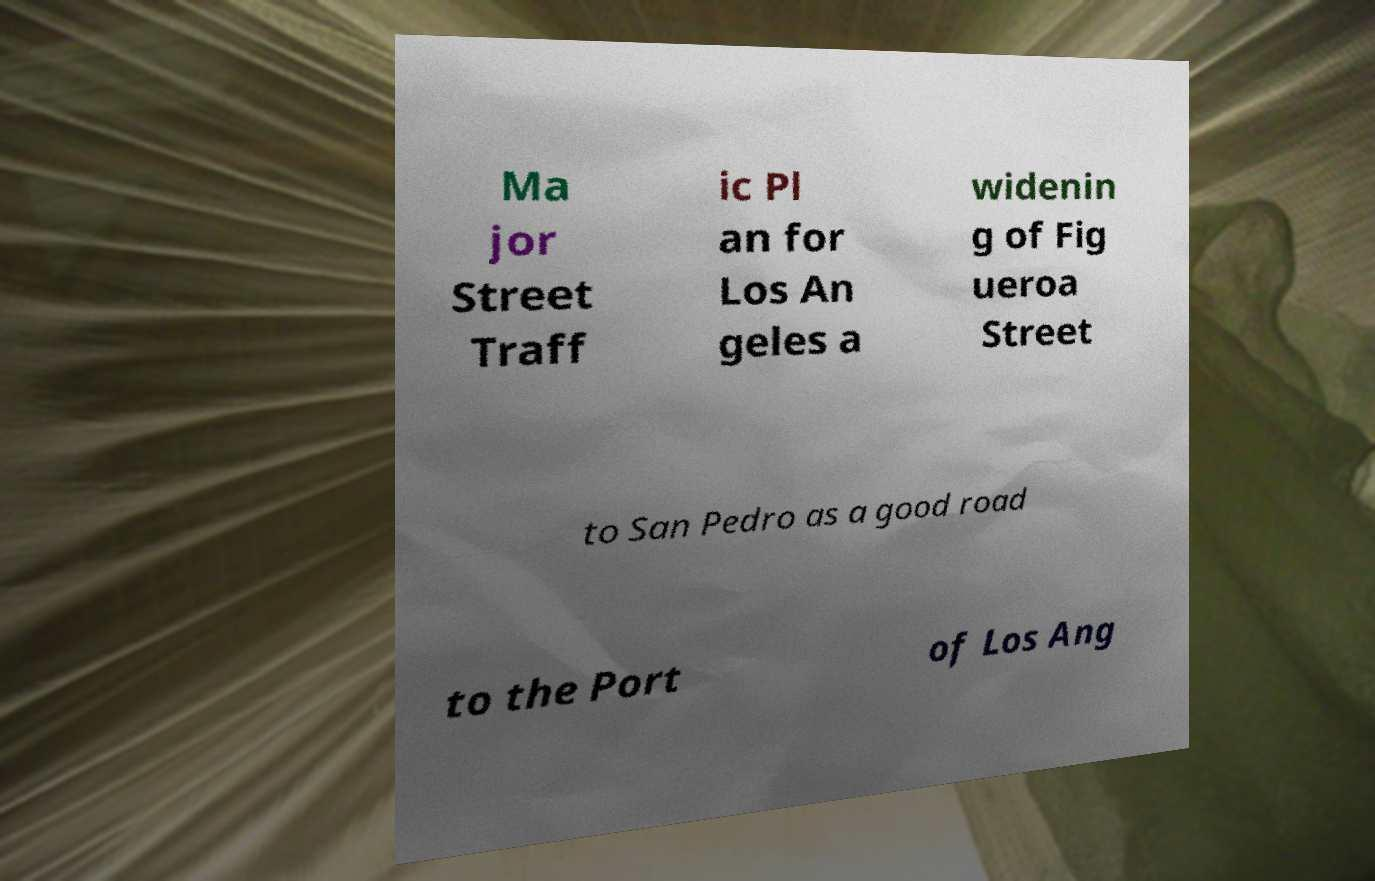There's text embedded in this image that I need extracted. Can you transcribe it verbatim? Ma jor Street Traff ic Pl an for Los An geles a widenin g of Fig ueroa Street to San Pedro as a good road to the Port of Los Ang 